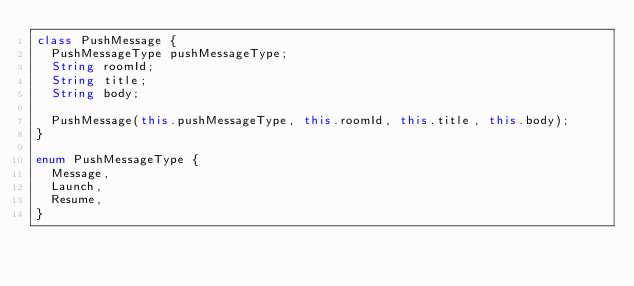<code> <loc_0><loc_0><loc_500><loc_500><_Dart_>class PushMessage {
  PushMessageType pushMessageType;
  String roomId;
  String title;
  String body;

  PushMessage(this.pushMessageType, this.roomId, this.title, this.body);
}

enum PushMessageType {
  Message,
  Launch,
  Resume,
}
</code> 